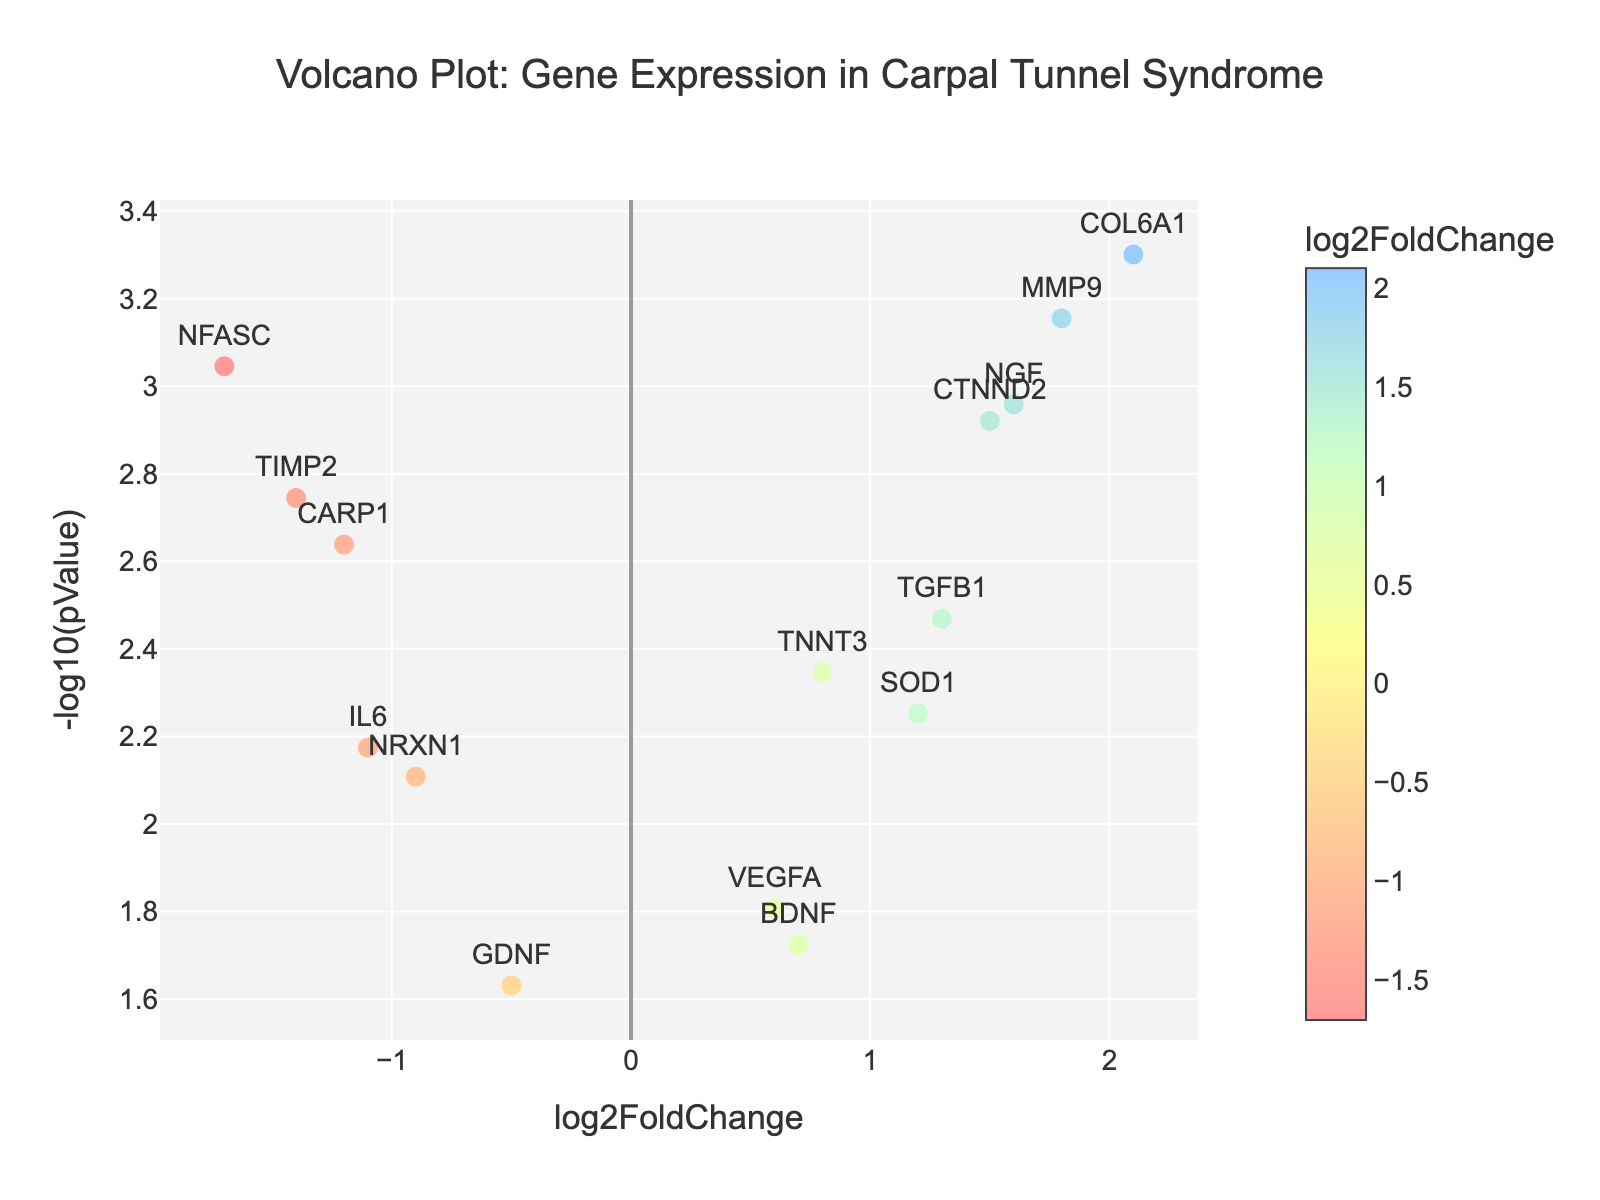What is the title of the figure? The title is positioned at the top of the plot and summarizes the content of the figure.
Answer: "Volcano Plot: Gene Expression in Carpal Tunnel Syndrome" How many genes have a log2FoldChange greater than 1? The log2FoldChange values are on the x-axis. Identify data points where the x-coordinate is greater than 1.
Answer: 5 What gene has the smallest pValue? The highest point on the y-axis represents the smallest pValue, as the y-axis represents -log10(pValue).
Answer: COL6A1 Which gene has the highest log2FoldChange value? Find the rightmost data point on the x-axis.
Answer: COL6A1 Which two genes have the largest absolute log2FoldChange values, and what are those values? Identify the leftmost and rightmost points as they have the largest negative and positive log2FoldChange values respectively.
Answer: NFASC (-1.7) and COL6A1 (2.1) Which gene is represented by a point near the coordinates (1.8, 3.15)? Locate the data point at the specified coordinates visually.
Answer: MMP9 How many genes have a pValue less than 0.005? Convert -log10(pValue) = 2.3 (since -log10(0.005) ≈ 2.3) and count data points above this y-coordinate.
Answer: 6 Which genes have a log2FoldChange less than -1 and a pValue less than 0.01? Identify data points to the left of x = -1 and above y = 2.
Answer: CARP1, NFASC, TIMP2 What is the average log2FoldChange of all the genes shown? Sum all log2FoldChange values and divide by the number of data points. Sum = -1.2 + 0.8 + 1.5 - 0.9 + 2.1 - 1.7 + 1.3 + 0.6 + 1.8 - 1.1 + 0.7 - 1.4 + 1.6 - 0.5 + 1.2 = 5.6. Divide by 15 (number of genes).
Answer: 0.37 